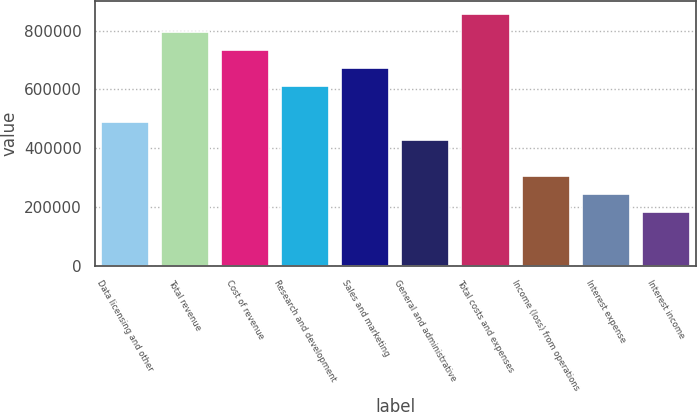Convert chart. <chart><loc_0><loc_0><loc_500><loc_500><bar_chart><fcel>Data licensing and other<fcel>Total revenue<fcel>Cost of revenue<fcel>Research and development<fcel>Sales and marketing<fcel>General and administrative<fcel>Total costs and expenses<fcel>Income (loss) from operations<fcel>Interest expense<fcel>Interest income<nl><fcel>489771<fcel>795878<fcel>734657<fcel>612214<fcel>673435<fcel>428550<fcel>857099<fcel>306107<fcel>244886<fcel>183664<nl></chart> 